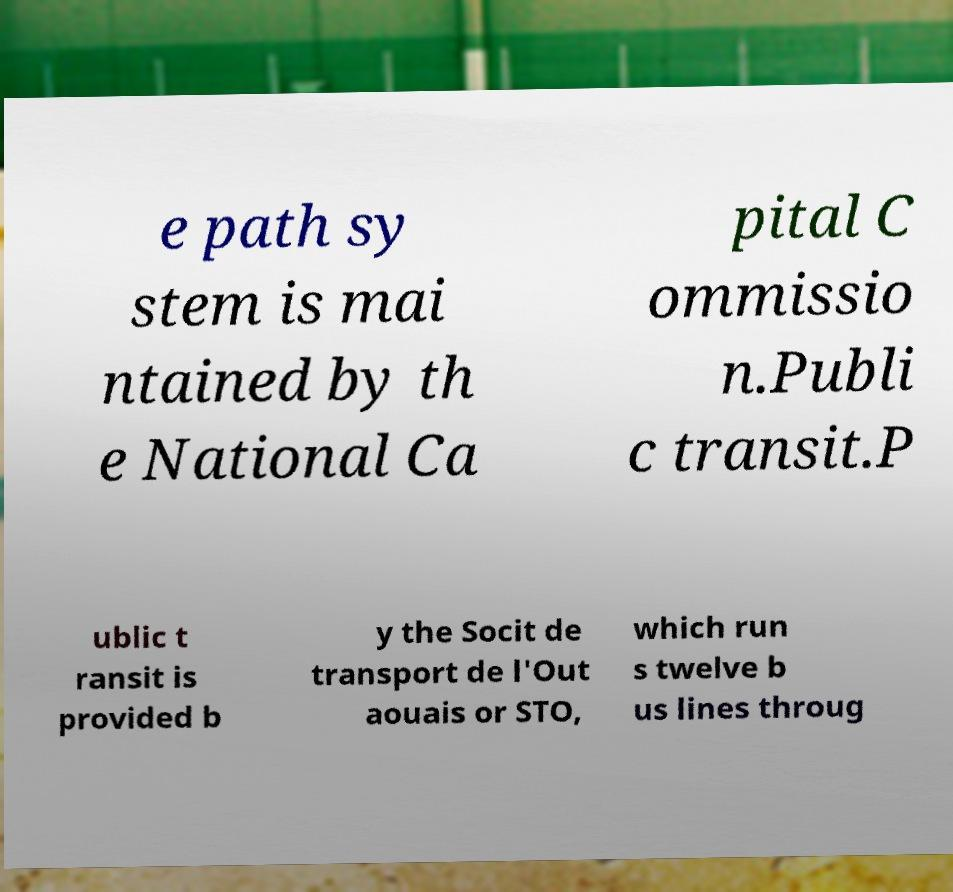For documentation purposes, I need the text within this image transcribed. Could you provide that? e path sy stem is mai ntained by th e National Ca pital C ommissio n.Publi c transit.P ublic t ransit is provided b y the Socit de transport de l'Out aouais or STO, which run s twelve b us lines throug 